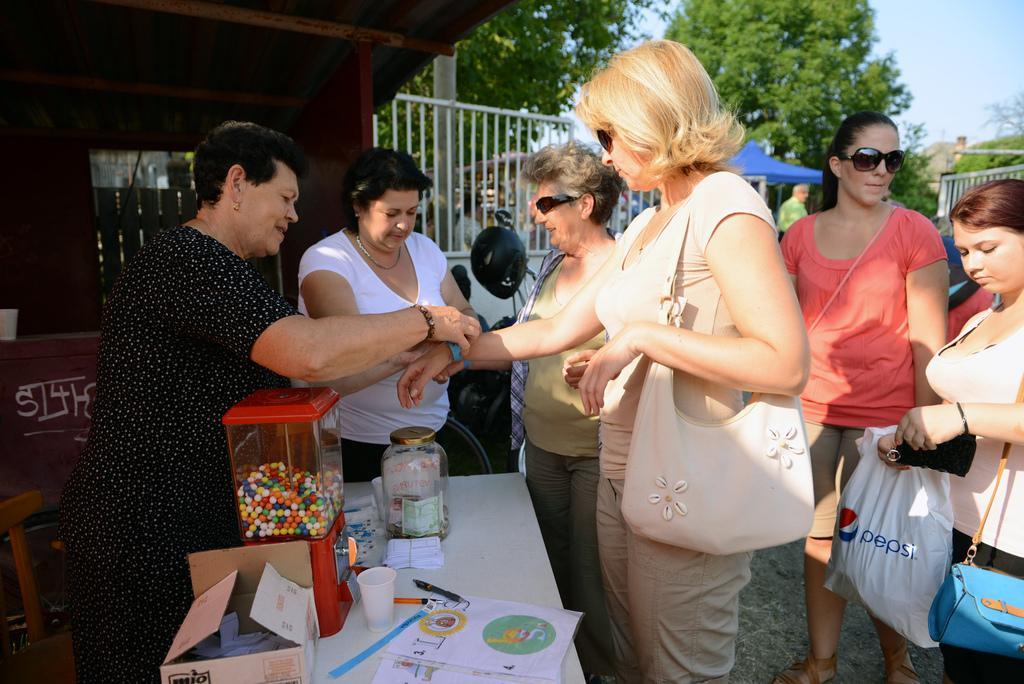In one or two sentences, can you explain what this image depicts? In this picture we can see the old woman standing in the front. Beside there is a woman wearing a black dress is holding her hand. In the background we can see the white railing fence, blue canopy shed and trees. 